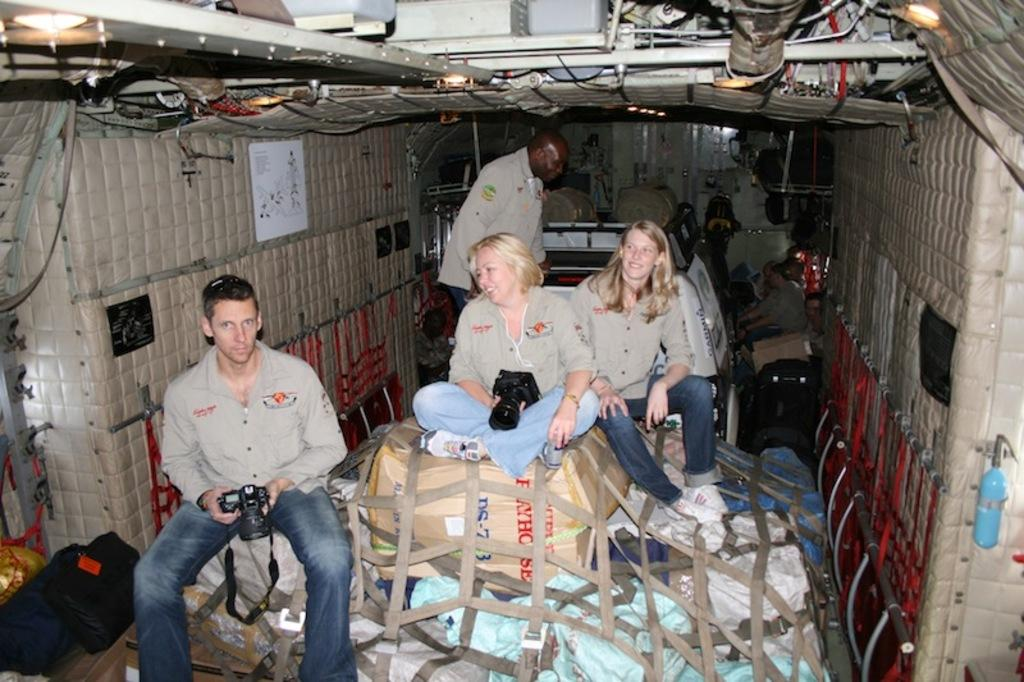Who or what is present in the image? There are people in the image. What object can be seen in the image besides the people? There is a carton box in the image. What devices are visible in the image? There are cameras in the image. What other items can be seen in the image? There are ropes and lights in the image. What type of pizzas are being served at the government meeting in the image? There is no mention of a government meeting or pizzas in the image; it features people, a carton box, cameras, ropes, and lights. 